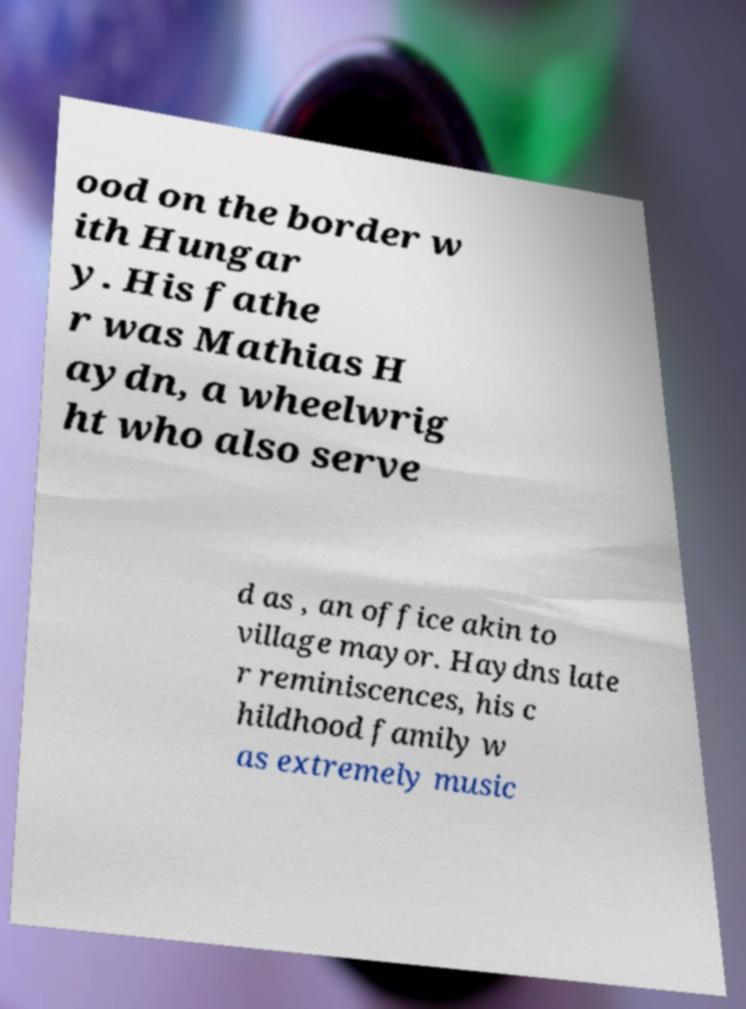What messages or text are displayed in this image? I need them in a readable, typed format. ood on the border w ith Hungar y. His fathe r was Mathias H aydn, a wheelwrig ht who also serve d as , an office akin to village mayor. Haydns late r reminiscences, his c hildhood family w as extremely music 